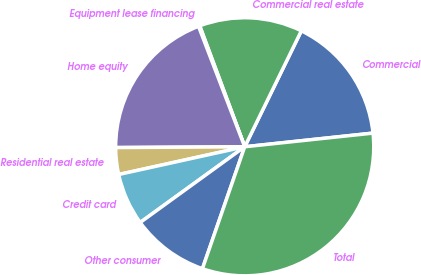Convert chart. <chart><loc_0><loc_0><loc_500><loc_500><pie_chart><fcel>Commercial<fcel>Commercial real estate<fcel>Equipment lease financing<fcel>Home equity<fcel>Residential real estate<fcel>Credit card<fcel>Other consumer<fcel>Total<nl><fcel>16.08%<fcel>12.9%<fcel>0.16%<fcel>19.27%<fcel>3.35%<fcel>6.53%<fcel>9.71%<fcel>32.0%<nl></chart> 